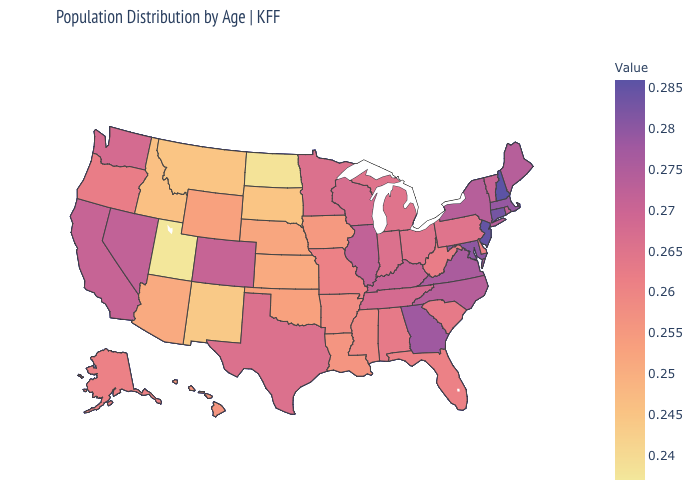Which states hav the highest value in the MidWest?
Answer briefly. Illinois. Among the states that border Kansas , which have the lowest value?
Be succinct. Nebraska. Which states have the highest value in the USA?
Write a very short answer. New Hampshire. Does Florida have a higher value than Arizona?
Give a very brief answer. Yes. Which states have the lowest value in the Northeast?
Short answer required. Pennsylvania. Among the states that border Florida , does Georgia have the lowest value?
Short answer required. No. Does Montana have the lowest value in the USA?
Answer briefly. No. 